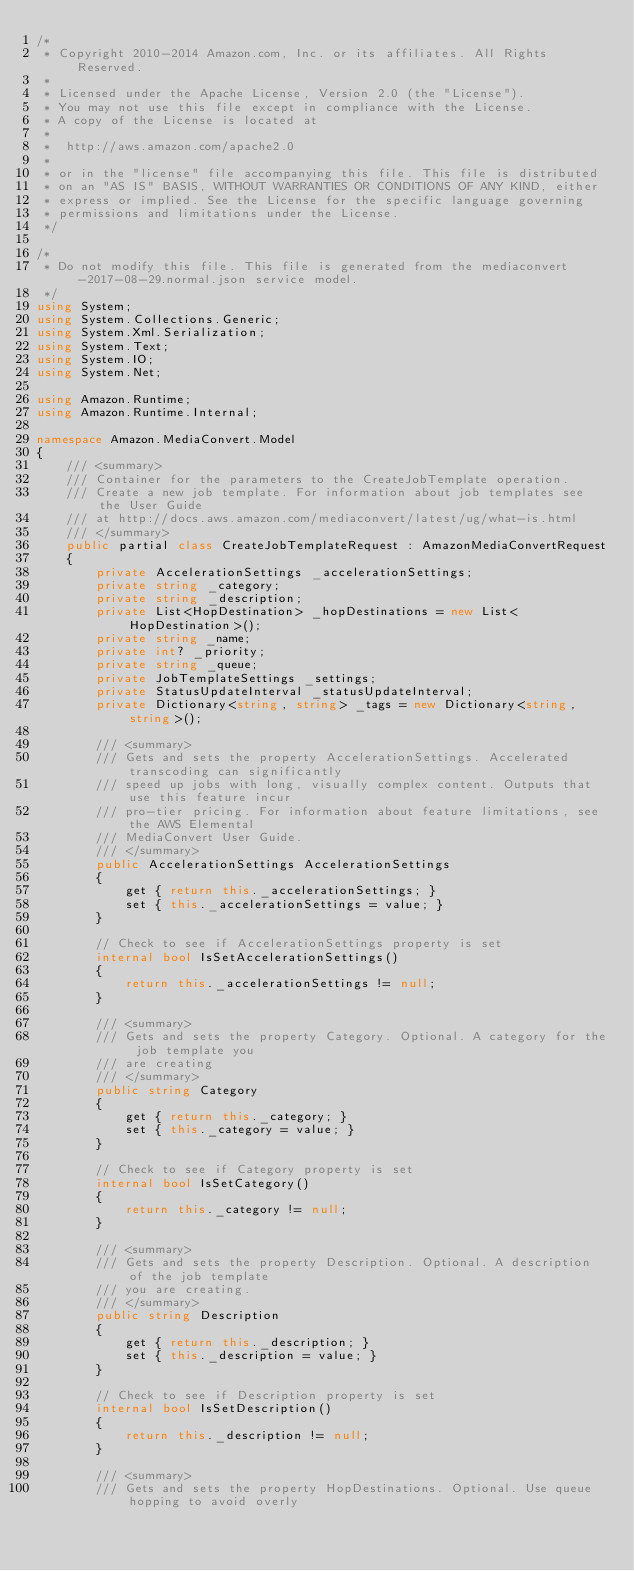<code> <loc_0><loc_0><loc_500><loc_500><_C#_>/*
 * Copyright 2010-2014 Amazon.com, Inc. or its affiliates. All Rights Reserved.
 * 
 * Licensed under the Apache License, Version 2.0 (the "License").
 * You may not use this file except in compliance with the License.
 * A copy of the License is located at
 * 
 *  http://aws.amazon.com/apache2.0
 * 
 * or in the "license" file accompanying this file. This file is distributed
 * on an "AS IS" BASIS, WITHOUT WARRANTIES OR CONDITIONS OF ANY KIND, either
 * express or implied. See the License for the specific language governing
 * permissions and limitations under the License.
 */

/*
 * Do not modify this file. This file is generated from the mediaconvert-2017-08-29.normal.json service model.
 */
using System;
using System.Collections.Generic;
using System.Xml.Serialization;
using System.Text;
using System.IO;
using System.Net;

using Amazon.Runtime;
using Amazon.Runtime.Internal;

namespace Amazon.MediaConvert.Model
{
    /// <summary>
    /// Container for the parameters to the CreateJobTemplate operation.
    /// Create a new job template. For information about job templates see the User Guide
    /// at http://docs.aws.amazon.com/mediaconvert/latest/ug/what-is.html
    /// </summary>
    public partial class CreateJobTemplateRequest : AmazonMediaConvertRequest
    {
        private AccelerationSettings _accelerationSettings;
        private string _category;
        private string _description;
        private List<HopDestination> _hopDestinations = new List<HopDestination>();
        private string _name;
        private int? _priority;
        private string _queue;
        private JobTemplateSettings _settings;
        private StatusUpdateInterval _statusUpdateInterval;
        private Dictionary<string, string> _tags = new Dictionary<string, string>();

        /// <summary>
        /// Gets and sets the property AccelerationSettings. Accelerated transcoding can significantly
        /// speed up jobs with long, visually complex content. Outputs that use this feature incur
        /// pro-tier pricing. For information about feature limitations, see the AWS Elemental
        /// MediaConvert User Guide.
        /// </summary>
        public AccelerationSettings AccelerationSettings
        {
            get { return this._accelerationSettings; }
            set { this._accelerationSettings = value; }
        }

        // Check to see if AccelerationSettings property is set
        internal bool IsSetAccelerationSettings()
        {
            return this._accelerationSettings != null;
        }

        /// <summary>
        /// Gets and sets the property Category. Optional. A category for the job template you
        /// are creating
        /// </summary>
        public string Category
        {
            get { return this._category; }
            set { this._category = value; }
        }

        // Check to see if Category property is set
        internal bool IsSetCategory()
        {
            return this._category != null;
        }

        /// <summary>
        /// Gets and sets the property Description. Optional. A description of the job template
        /// you are creating.
        /// </summary>
        public string Description
        {
            get { return this._description; }
            set { this._description = value; }
        }

        // Check to see if Description property is set
        internal bool IsSetDescription()
        {
            return this._description != null;
        }

        /// <summary>
        /// Gets and sets the property HopDestinations. Optional. Use queue hopping to avoid overly</code> 